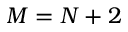Convert formula to latex. <formula><loc_0><loc_0><loc_500><loc_500>M = N + 2</formula> 